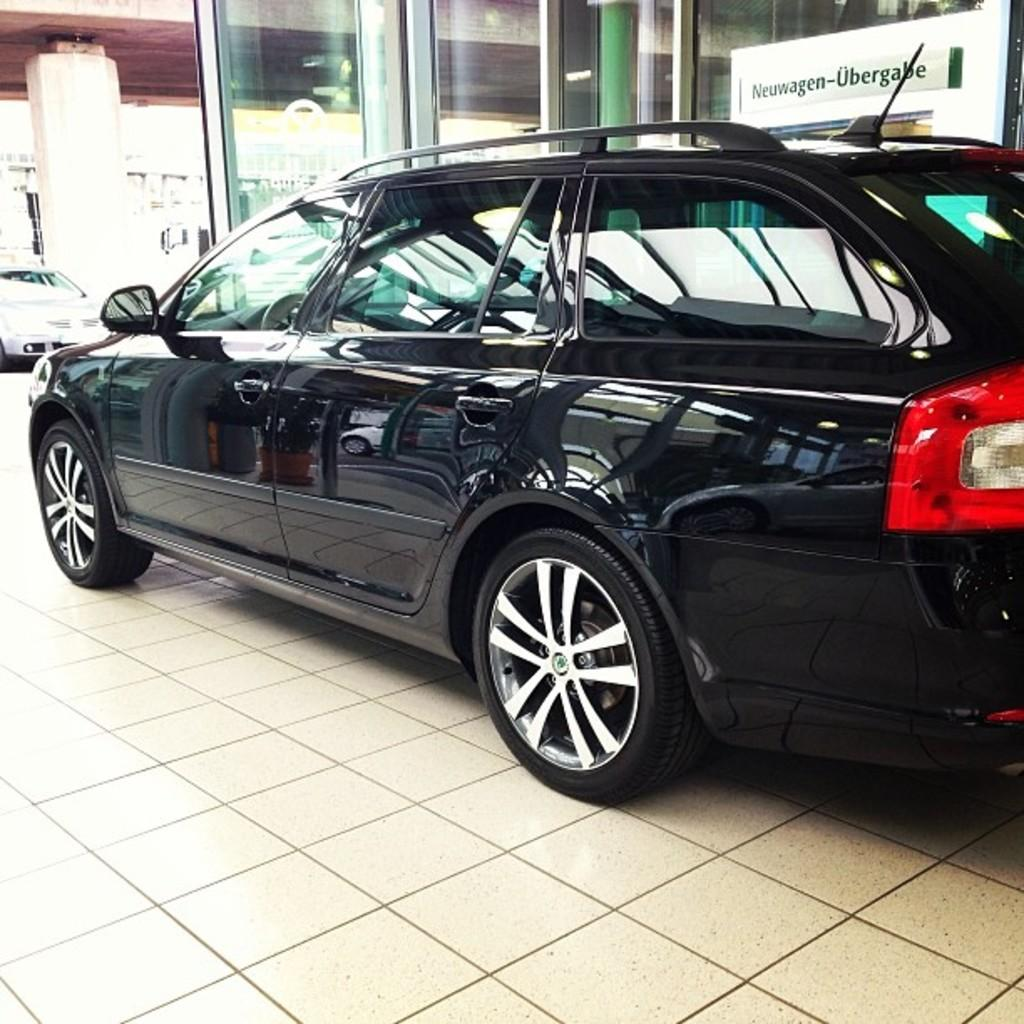What objects are on the floor in the image? There are motor vehicles on the floor in the image. What can be seen in the distance in the image? There are buildings in the background of the image. What items are visible in the background, aside from the buildings? There are glasses and a name board in the background of the image. What type of reaction can be seen from the bear in the image? There is no bear present in the image, so it is not possible to determine any reaction from a bear. 